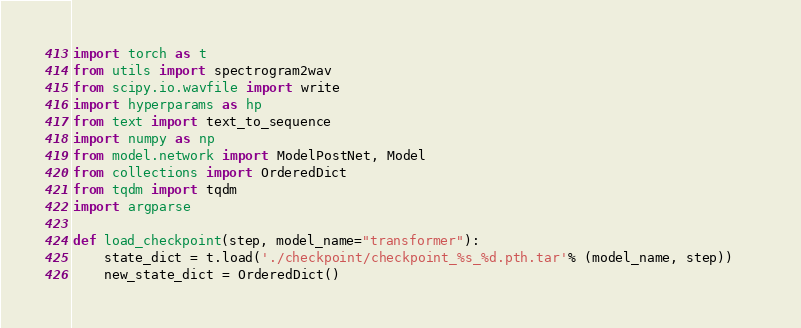<code> <loc_0><loc_0><loc_500><loc_500><_Python_>import torch as t
from utils import spectrogram2wav
from scipy.io.wavfile import write
import hyperparams as hp
from text import text_to_sequence
import numpy as np
from model.network import ModelPostNet, Model
from collections import OrderedDict
from tqdm import tqdm
import argparse

def load_checkpoint(step, model_name="transformer"):
    state_dict = t.load('./checkpoint/checkpoint_%s_%d.pth.tar'% (model_name, step))   
    new_state_dict = OrderedDict()</code> 